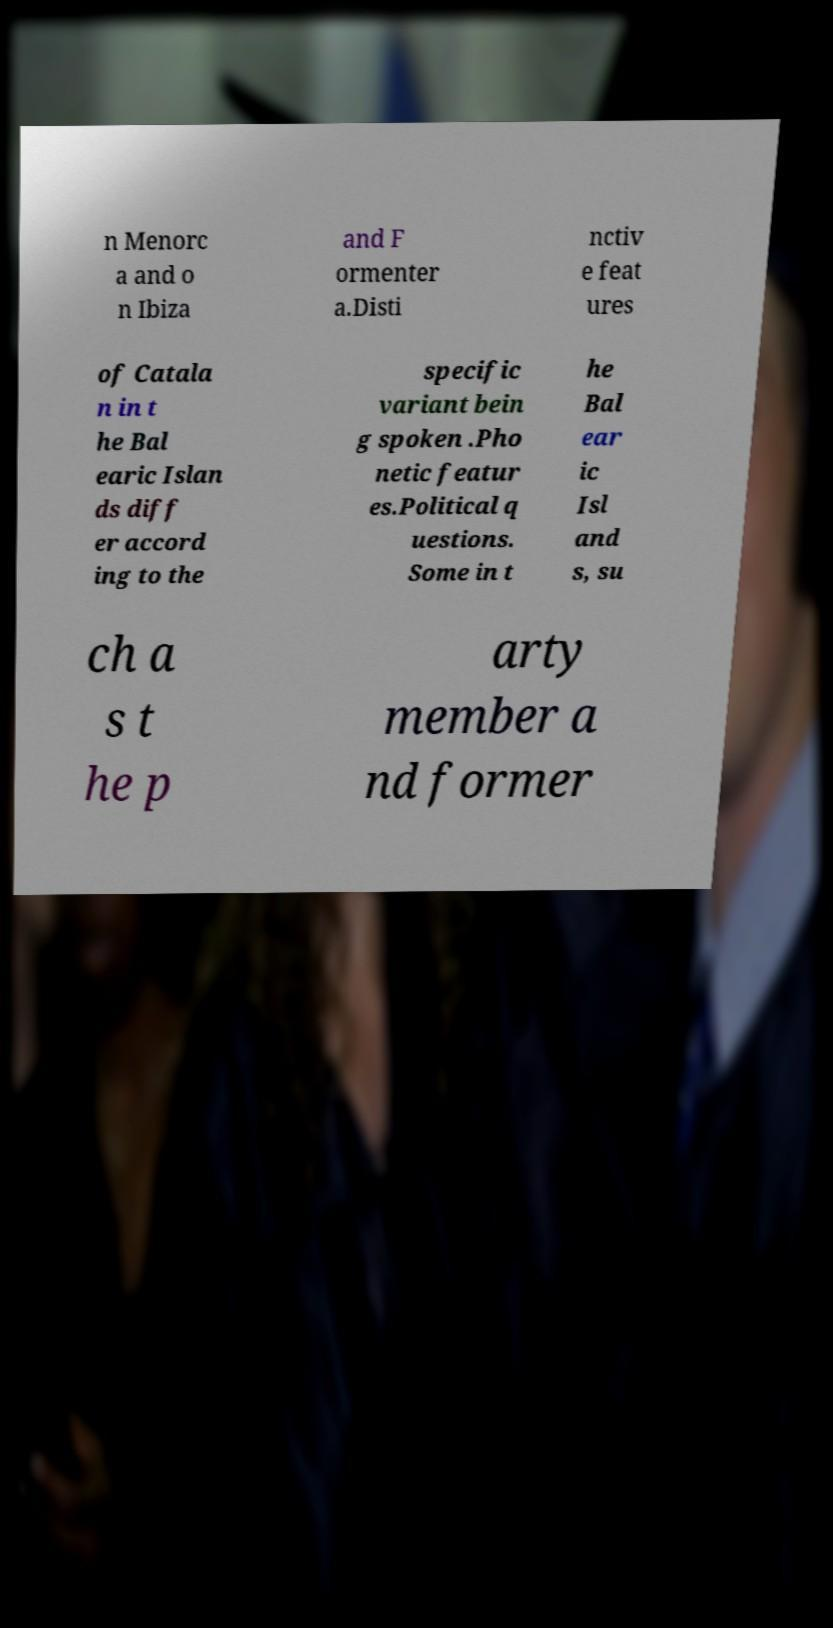For documentation purposes, I need the text within this image transcribed. Could you provide that? n Menorc a and o n Ibiza and F ormenter a.Disti nctiv e feat ures of Catala n in t he Bal earic Islan ds diff er accord ing to the specific variant bein g spoken .Pho netic featur es.Political q uestions. Some in t he Bal ear ic Isl and s, su ch a s t he p arty member a nd former 